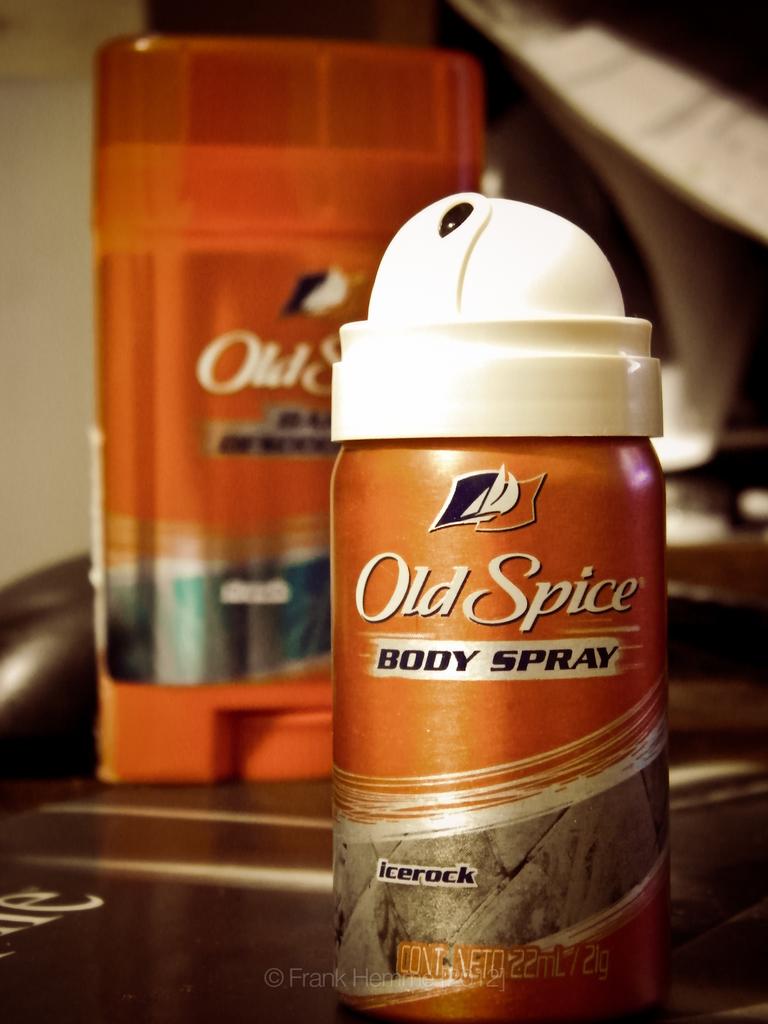What kind of spray is it?
Give a very brief answer. Body. What is the scent of this old spice?
Offer a very short reply. Icerock. 